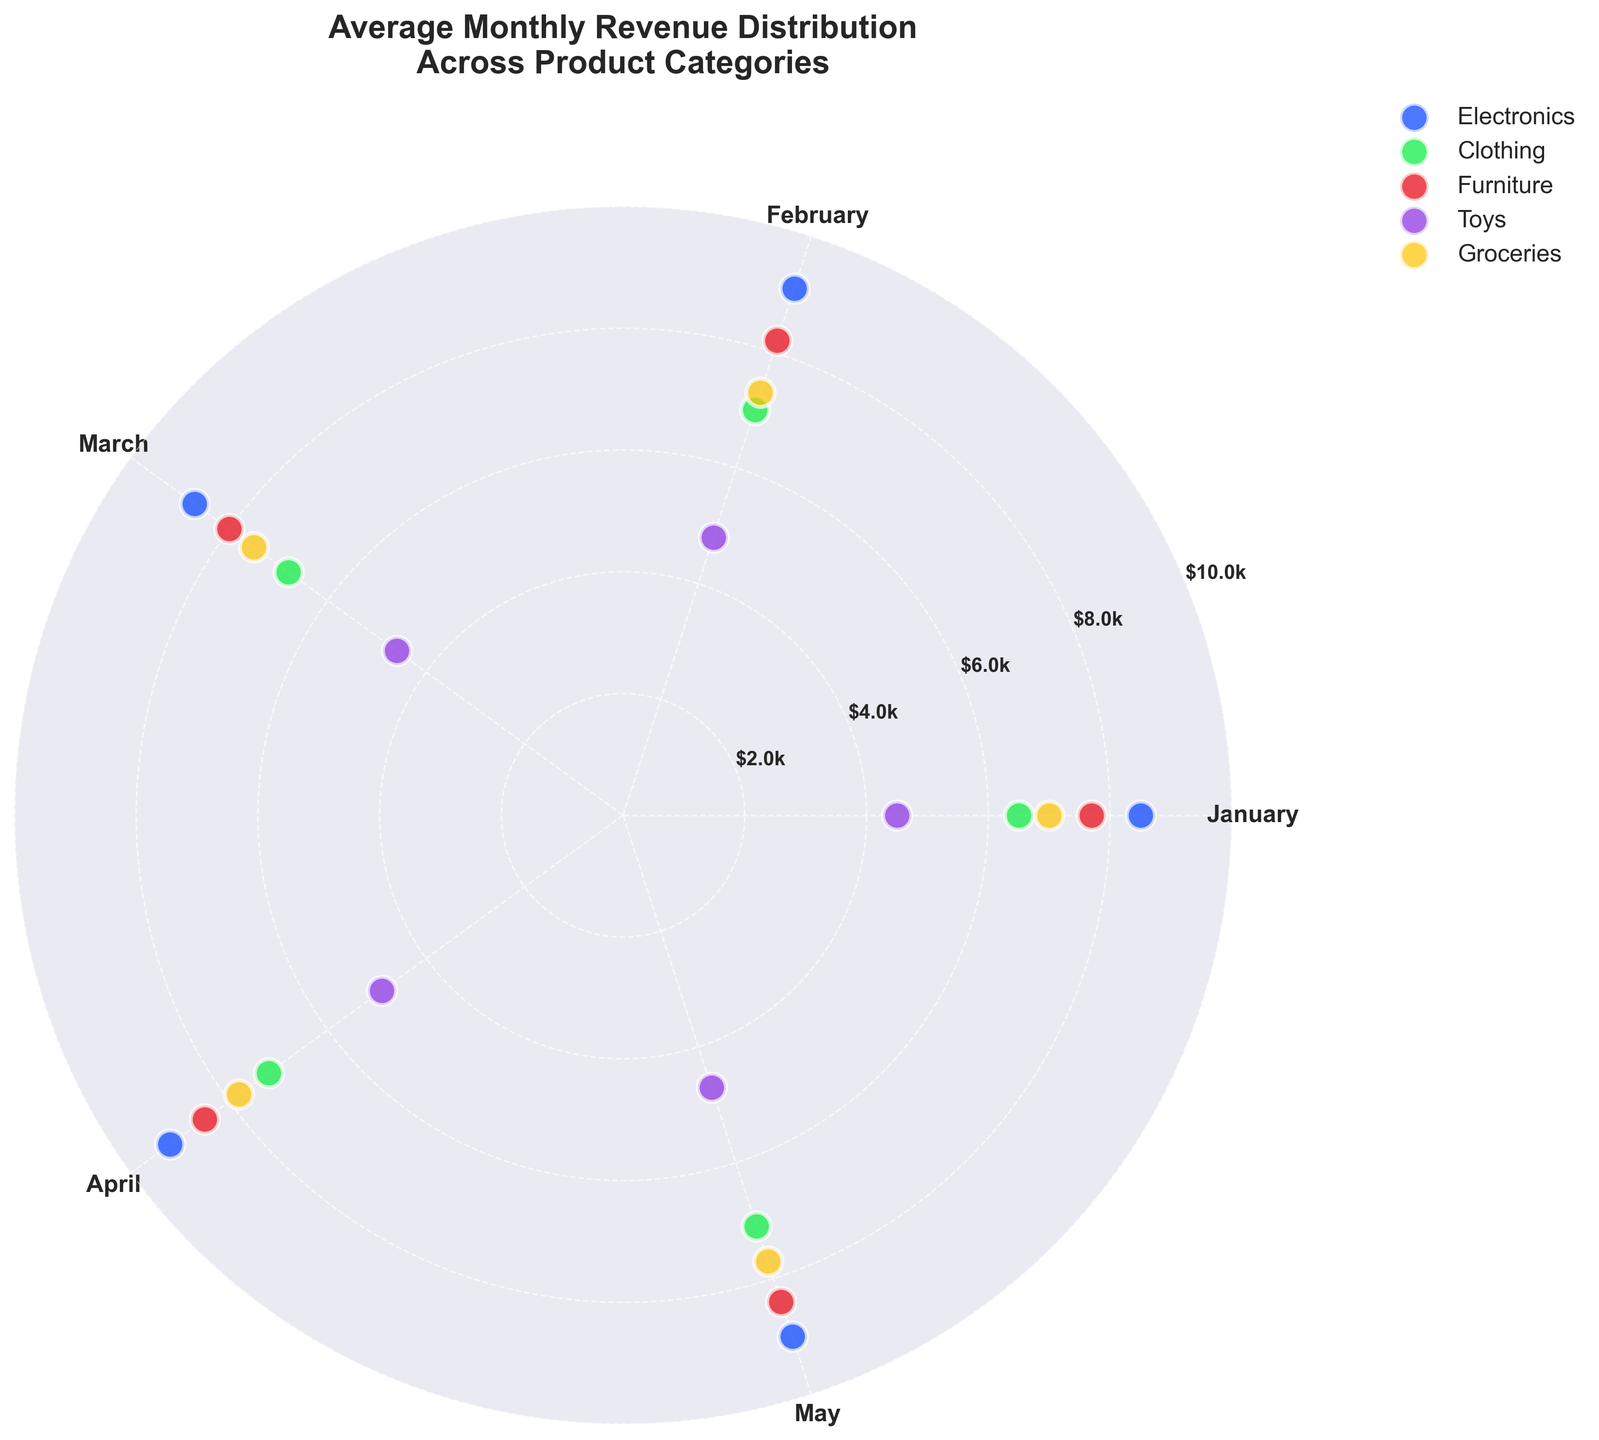What is the title of the chart? The title is typically displayed at the top center of the chart. Here it reads "Average Monthly Revenue Distribution Across Product Categories."
Answer: Average Monthly Revenue Distribution Across Product Categories Which month recorded the highest average revenue for the Electronics category? By inspecting the angles corresponding to months for the Electronics category, the highest average revenue is in April at $9200.
Answer: April Which product category has the lowest average revenue in January? Situating January's angle and looking at all categories, the Toys category has the lowest average revenue in January at $4500.
Answer: Toys How many distinct product categories are shown in the chart? Each scatter point is labeled by category in the legend. There are five labels: Electronics, Clothing, Furniture, Toys, and Groceries.
Answer: 5 During which month did Groceries show the highest average revenue? By aligning Groceries' data points to their respective months, April exhibits the highest average revenue at $7800.
Answer: April Compare the average revenue for Electronics between January and February. Which month had a higher value? Observing the scatter points for Electronics, January's revenue is $8500, and February's is $9100. February has a higher value.
Answer: February What is the range of average revenues for the Furniture category from January to May? Examining Furniture's data points from January to May, the values span from $7700 to $8500. The range is $8500 - $7700 = $800.
Answer: $800 On average, how much more or less revenue did Toy sales generate compared to Clothing sales in March? Toys in March: $4600, Clothing in March: $6800. The difference is $6800 - $4600 = $2200.
Answer: $2200 less Which product category shows the least variation in average revenue across the months displayed? Variation can be measured by the spread of data points. Comparing distances, Toys have the smallest variation from $4500 to $4900.
Answer: Toys Are there any months where all categories have an average revenue above $5000? Checking each month's scatter points, we find all categories exceed $5000 in April and May.
Answer: April, May 